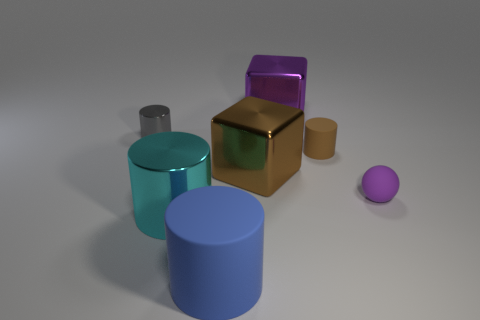What is the color of the other big shiny object that is the same shape as the large purple metal thing?
Keep it short and to the point. Brown. There is a small brown thing; is its shape the same as the purple thing that is behind the gray object?
Provide a succinct answer. No. What number of objects are big blocks that are left of the big purple thing or big objects that are behind the small brown matte thing?
Your answer should be very brief. 2. What is the large blue cylinder made of?
Your answer should be compact. Rubber. How many other objects are the same size as the cyan cylinder?
Make the answer very short. 3. How big is the matte cylinder right of the blue cylinder?
Provide a short and direct response. Small. The small cylinder that is to the right of the metallic cylinder in front of the tiny gray thing that is left of the small matte sphere is made of what material?
Offer a very short reply. Rubber. Is the cyan object the same shape as the gray metal object?
Offer a terse response. Yes. What number of rubber things are either tiny cylinders or big gray cubes?
Provide a succinct answer. 1. What number of big purple metallic cubes are there?
Your response must be concise. 1. 